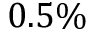<formula> <loc_0><loc_0><loc_500><loc_500>0 . 5 \%</formula> 